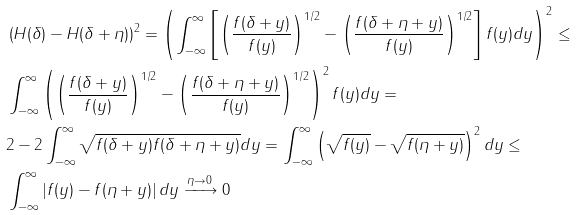Convert formula to latex. <formula><loc_0><loc_0><loc_500><loc_500>& \left ( H ( \delta ) - H ( \delta + \eta ) \right ) ^ { 2 } = \left ( \int _ { - \infty } ^ { \infty } \left [ \left ( \frac { f ( \delta + y ) } { f ( y ) } \right ) ^ { 1 / 2 } - \left ( \frac { f ( \delta + \eta + y ) } { f ( y ) } \right ) ^ { 1 / 2 } \right ] f ( y ) d y \right ) ^ { 2 } \leq \\ & \int _ { - \infty } ^ { \infty } \left ( \left ( \frac { f ( \delta + y ) } { f ( y ) } \right ) ^ { 1 / 2 } - \left ( \frac { f ( \delta + \eta + y ) } { f ( y ) } \right ) ^ { 1 / 2 } \right ) ^ { 2 } f ( y ) d y = \\ & 2 - 2 \int _ { - \infty } ^ { \infty } \sqrt { f ( \delta + y ) f ( \delta + \eta + y ) } d y = \int _ { - \infty } ^ { \infty } \left ( \sqrt { f ( y ) } - \sqrt { f ( \eta + y ) } \right ) ^ { 2 } d y \leq \\ & \int _ { - \infty } ^ { \infty } \left | f ( y ) - f ( \eta + y ) \right | d y \xrightarrow { \eta \to 0 } 0</formula> 